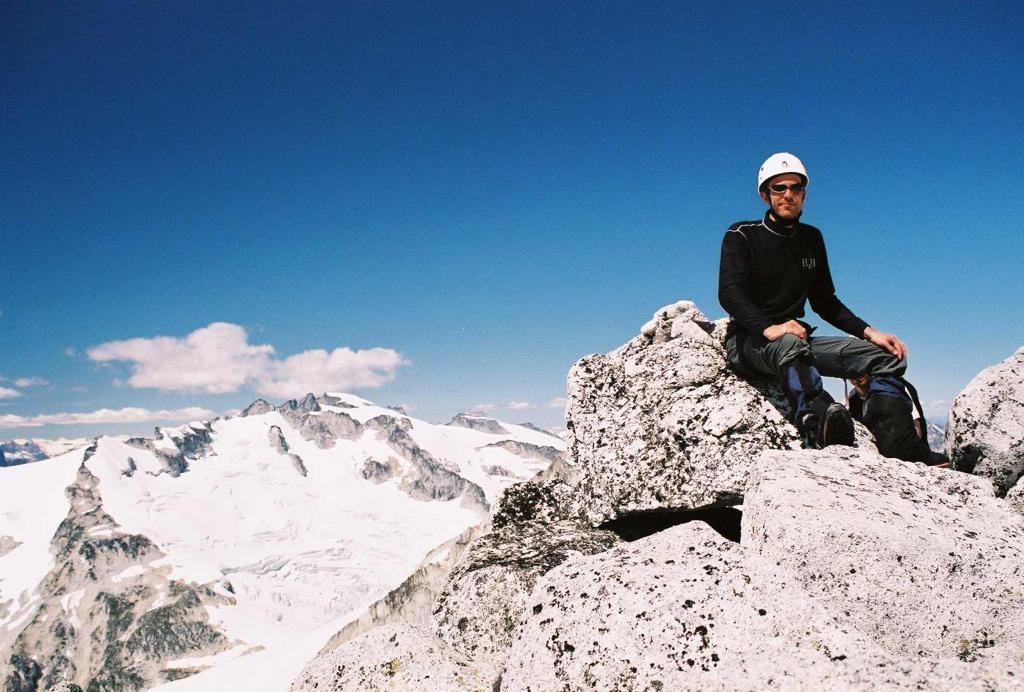Describe this image in one or two sentences. In this image, I can see the man sitting on the rock. This looks like a snowy mountain. These are the clouds in the sky. 